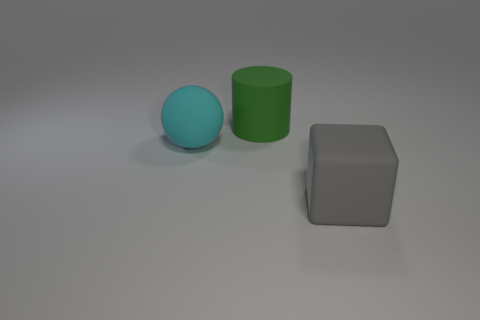Is the green matte object the same size as the rubber cube?
Offer a terse response. Yes. What number of cubes are either small green rubber objects or gray rubber objects?
Ensure brevity in your answer.  1. What number of big green things are behind the large object to the right of the green matte thing?
Your answer should be very brief. 1. Does the large gray thing have the same shape as the cyan matte object?
Keep it short and to the point. No. There is a matte thing that is to the left of the large thing behind the big cyan matte object; what shape is it?
Keep it short and to the point. Sphere. The cyan matte ball is what size?
Offer a terse response. Large. The big gray thing has what shape?
Make the answer very short. Cube. There is a large gray matte thing; is its shape the same as the large object behind the cyan thing?
Give a very brief answer. No. There is a big thing that is behind the sphere; is its shape the same as the large cyan rubber thing?
Provide a short and direct response. No. What number of things are behind the big sphere and in front of the large cylinder?
Your answer should be compact. 0. 